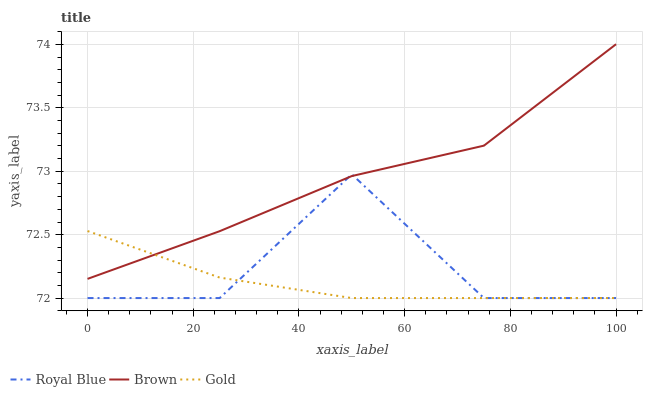Does Gold have the minimum area under the curve?
Answer yes or no. Yes. Does Brown have the maximum area under the curve?
Answer yes or no. Yes. Does Brown have the minimum area under the curve?
Answer yes or no. No. Does Gold have the maximum area under the curve?
Answer yes or no. No. Is Gold the smoothest?
Answer yes or no. Yes. Is Royal Blue the roughest?
Answer yes or no. Yes. Is Brown the smoothest?
Answer yes or no. No. Is Brown the roughest?
Answer yes or no. No. Does Brown have the lowest value?
Answer yes or no. No. Does Gold have the highest value?
Answer yes or no. No. 